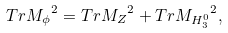<formula> <loc_0><loc_0><loc_500><loc_500>T r { \sl M _ { \phi } } ^ { 2 } = T r { \sl M _ { Z } } ^ { 2 } + T r { \sl M _ { H _ { 3 } ^ { 0 } } } ^ { 2 } ,</formula> 